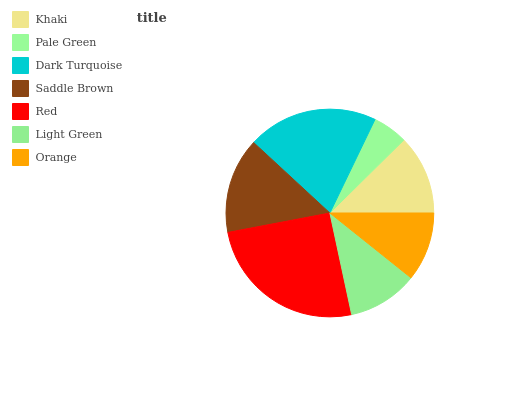Is Pale Green the minimum?
Answer yes or no. Yes. Is Red the maximum?
Answer yes or no. Yes. Is Dark Turquoise the minimum?
Answer yes or no. No. Is Dark Turquoise the maximum?
Answer yes or no. No. Is Dark Turquoise greater than Pale Green?
Answer yes or no. Yes. Is Pale Green less than Dark Turquoise?
Answer yes or no. Yes. Is Pale Green greater than Dark Turquoise?
Answer yes or no. No. Is Dark Turquoise less than Pale Green?
Answer yes or no. No. Is Khaki the high median?
Answer yes or no. Yes. Is Khaki the low median?
Answer yes or no. Yes. Is Pale Green the high median?
Answer yes or no. No. Is Light Green the low median?
Answer yes or no. No. 